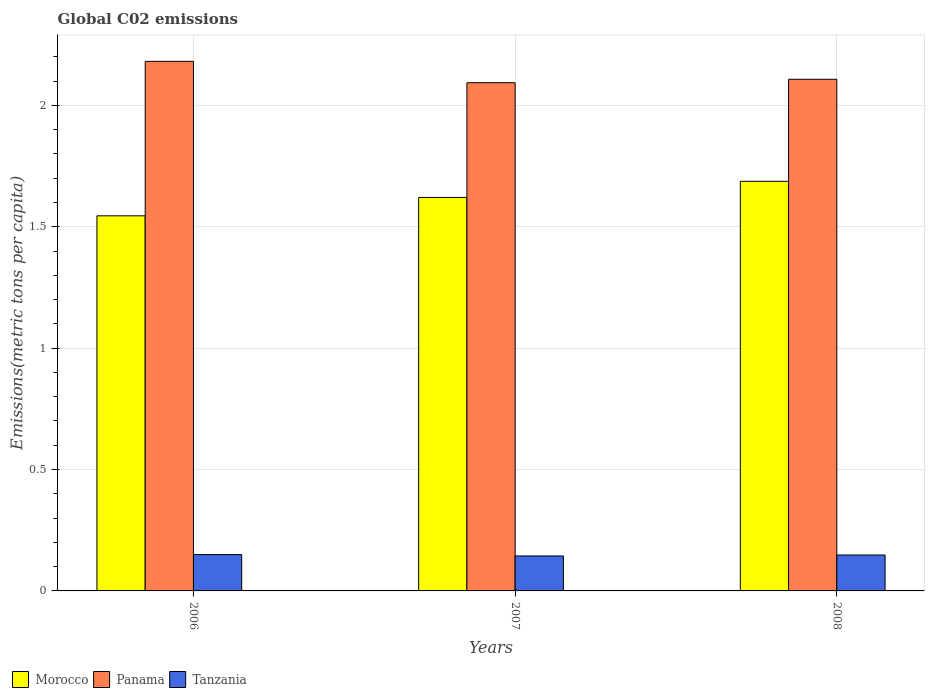How many different coloured bars are there?
Make the answer very short. 3. How many groups of bars are there?
Provide a succinct answer. 3. How many bars are there on the 3rd tick from the left?
Offer a very short reply. 3. What is the amount of CO2 emitted in in Tanzania in 2008?
Offer a very short reply. 0.15. Across all years, what is the maximum amount of CO2 emitted in in Tanzania?
Ensure brevity in your answer.  0.15. Across all years, what is the minimum amount of CO2 emitted in in Morocco?
Your answer should be very brief. 1.55. In which year was the amount of CO2 emitted in in Tanzania minimum?
Give a very brief answer. 2007. What is the total amount of CO2 emitted in in Panama in the graph?
Provide a succinct answer. 6.38. What is the difference between the amount of CO2 emitted in in Tanzania in 2007 and that in 2008?
Your answer should be compact. -0. What is the difference between the amount of CO2 emitted in in Morocco in 2008 and the amount of CO2 emitted in in Tanzania in 2006?
Your answer should be very brief. 1.54. What is the average amount of CO2 emitted in in Morocco per year?
Give a very brief answer. 1.62. In the year 2007, what is the difference between the amount of CO2 emitted in in Panama and amount of CO2 emitted in in Tanzania?
Your answer should be very brief. 1.95. What is the ratio of the amount of CO2 emitted in in Morocco in 2007 to that in 2008?
Keep it short and to the point. 0.96. Is the amount of CO2 emitted in in Morocco in 2007 less than that in 2008?
Ensure brevity in your answer.  Yes. What is the difference between the highest and the second highest amount of CO2 emitted in in Tanzania?
Make the answer very short. 0. What is the difference between the highest and the lowest amount of CO2 emitted in in Morocco?
Give a very brief answer. 0.14. What does the 1st bar from the left in 2006 represents?
Your answer should be compact. Morocco. What does the 3rd bar from the right in 2007 represents?
Keep it short and to the point. Morocco. Is it the case that in every year, the sum of the amount of CO2 emitted in in Tanzania and amount of CO2 emitted in in Panama is greater than the amount of CO2 emitted in in Morocco?
Your answer should be very brief. Yes. How many years are there in the graph?
Provide a short and direct response. 3. Where does the legend appear in the graph?
Offer a very short reply. Bottom left. How are the legend labels stacked?
Your answer should be compact. Horizontal. What is the title of the graph?
Provide a succinct answer. Global C02 emissions. What is the label or title of the Y-axis?
Your answer should be very brief. Emissions(metric tons per capita). What is the Emissions(metric tons per capita) in Morocco in 2006?
Offer a terse response. 1.55. What is the Emissions(metric tons per capita) in Panama in 2006?
Give a very brief answer. 2.18. What is the Emissions(metric tons per capita) in Tanzania in 2006?
Offer a terse response. 0.15. What is the Emissions(metric tons per capita) of Morocco in 2007?
Ensure brevity in your answer.  1.62. What is the Emissions(metric tons per capita) of Panama in 2007?
Offer a terse response. 2.09. What is the Emissions(metric tons per capita) of Tanzania in 2007?
Your response must be concise. 0.14. What is the Emissions(metric tons per capita) in Morocco in 2008?
Provide a short and direct response. 1.69. What is the Emissions(metric tons per capita) in Panama in 2008?
Give a very brief answer. 2.11. What is the Emissions(metric tons per capita) of Tanzania in 2008?
Provide a short and direct response. 0.15. Across all years, what is the maximum Emissions(metric tons per capita) of Morocco?
Give a very brief answer. 1.69. Across all years, what is the maximum Emissions(metric tons per capita) of Panama?
Your answer should be very brief. 2.18. Across all years, what is the maximum Emissions(metric tons per capita) in Tanzania?
Offer a very short reply. 0.15. Across all years, what is the minimum Emissions(metric tons per capita) of Morocco?
Make the answer very short. 1.55. Across all years, what is the minimum Emissions(metric tons per capita) of Panama?
Offer a very short reply. 2.09. Across all years, what is the minimum Emissions(metric tons per capita) of Tanzania?
Your answer should be very brief. 0.14. What is the total Emissions(metric tons per capita) of Morocco in the graph?
Your response must be concise. 4.85. What is the total Emissions(metric tons per capita) in Panama in the graph?
Your answer should be very brief. 6.38. What is the total Emissions(metric tons per capita) of Tanzania in the graph?
Your response must be concise. 0.44. What is the difference between the Emissions(metric tons per capita) in Morocco in 2006 and that in 2007?
Make the answer very short. -0.08. What is the difference between the Emissions(metric tons per capita) in Panama in 2006 and that in 2007?
Provide a succinct answer. 0.09. What is the difference between the Emissions(metric tons per capita) of Tanzania in 2006 and that in 2007?
Your response must be concise. 0.01. What is the difference between the Emissions(metric tons per capita) in Morocco in 2006 and that in 2008?
Offer a terse response. -0.14. What is the difference between the Emissions(metric tons per capita) of Panama in 2006 and that in 2008?
Make the answer very short. 0.07. What is the difference between the Emissions(metric tons per capita) of Tanzania in 2006 and that in 2008?
Offer a very short reply. 0. What is the difference between the Emissions(metric tons per capita) of Morocco in 2007 and that in 2008?
Keep it short and to the point. -0.07. What is the difference between the Emissions(metric tons per capita) of Panama in 2007 and that in 2008?
Your response must be concise. -0.01. What is the difference between the Emissions(metric tons per capita) in Tanzania in 2007 and that in 2008?
Your answer should be very brief. -0. What is the difference between the Emissions(metric tons per capita) in Morocco in 2006 and the Emissions(metric tons per capita) in Panama in 2007?
Keep it short and to the point. -0.55. What is the difference between the Emissions(metric tons per capita) of Morocco in 2006 and the Emissions(metric tons per capita) of Tanzania in 2007?
Offer a very short reply. 1.4. What is the difference between the Emissions(metric tons per capita) of Panama in 2006 and the Emissions(metric tons per capita) of Tanzania in 2007?
Give a very brief answer. 2.04. What is the difference between the Emissions(metric tons per capita) of Morocco in 2006 and the Emissions(metric tons per capita) of Panama in 2008?
Offer a terse response. -0.56. What is the difference between the Emissions(metric tons per capita) in Morocco in 2006 and the Emissions(metric tons per capita) in Tanzania in 2008?
Make the answer very short. 1.4. What is the difference between the Emissions(metric tons per capita) of Panama in 2006 and the Emissions(metric tons per capita) of Tanzania in 2008?
Keep it short and to the point. 2.03. What is the difference between the Emissions(metric tons per capita) of Morocco in 2007 and the Emissions(metric tons per capita) of Panama in 2008?
Keep it short and to the point. -0.49. What is the difference between the Emissions(metric tons per capita) of Morocco in 2007 and the Emissions(metric tons per capita) of Tanzania in 2008?
Ensure brevity in your answer.  1.47. What is the difference between the Emissions(metric tons per capita) of Panama in 2007 and the Emissions(metric tons per capita) of Tanzania in 2008?
Ensure brevity in your answer.  1.95. What is the average Emissions(metric tons per capita) of Morocco per year?
Your answer should be compact. 1.62. What is the average Emissions(metric tons per capita) of Panama per year?
Make the answer very short. 2.13. What is the average Emissions(metric tons per capita) of Tanzania per year?
Ensure brevity in your answer.  0.15. In the year 2006, what is the difference between the Emissions(metric tons per capita) in Morocco and Emissions(metric tons per capita) in Panama?
Ensure brevity in your answer.  -0.64. In the year 2006, what is the difference between the Emissions(metric tons per capita) in Morocco and Emissions(metric tons per capita) in Tanzania?
Your response must be concise. 1.4. In the year 2006, what is the difference between the Emissions(metric tons per capita) in Panama and Emissions(metric tons per capita) in Tanzania?
Your answer should be compact. 2.03. In the year 2007, what is the difference between the Emissions(metric tons per capita) of Morocco and Emissions(metric tons per capita) of Panama?
Keep it short and to the point. -0.47. In the year 2007, what is the difference between the Emissions(metric tons per capita) in Morocco and Emissions(metric tons per capita) in Tanzania?
Offer a very short reply. 1.48. In the year 2007, what is the difference between the Emissions(metric tons per capita) in Panama and Emissions(metric tons per capita) in Tanzania?
Your answer should be compact. 1.95. In the year 2008, what is the difference between the Emissions(metric tons per capita) in Morocco and Emissions(metric tons per capita) in Panama?
Your response must be concise. -0.42. In the year 2008, what is the difference between the Emissions(metric tons per capita) in Morocco and Emissions(metric tons per capita) in Tanzania?
Provide a short and direct response. 1.54. In the year 2008, what is the difference between the Emissions(metric tons per capita) of Panama and Emissions(metric tons per capita) of Tanzania?
Keep it short and to the point. 1.96. What is the ratio of the Emissions(metric tons per capita) in Morocco in 2006 to that in 2007?
Keep it short and to the point. 0.95. What is the ratio of the Emissions(metric tons per capita) of Panama in 2006 to that in 2007?
Provide a succinct answer. 1.04. What is the ratio of the Emissions(metric tons per capita) in Tanzania in 2006 to that in 2007?
Make the answer very short. 1.04. What is the ratio of the Emissions(metric tons per capita) in Morocco in 2006 to that in 2008?
Keep it short and to the point. 0.92. What is the ratio of the Emissions(metric tons per capita) of Panama in 2006 to that in 2008?
Offer a terse response. 1.03. What is the ratio of the Emissions(metric tons per capita) of Tanzania in 2006 to that in 2008?
Offer a terse response. 1.01. What is the ratio of the Emissions(metric tons per capita) of Morocco in 2007 to that in 2008?
Provide a short and direct response. 0.96. What is the ratio of the Emissions(metric tons per capita) in Tanzania in 2007 to that in 2008?
Make the answer very short. 0.97. What is the difference between the highest and the second highest Emissions(metric tons per capita) in Morocco?
Provide a succinct answer. 0.07. What is the difference between the highest and the second highest Emissions(metric tons per capita) in Panama?
Make the answer very short. 0.07. What is the difference between the highest and the second highest Emissions(metric tons per capita) of Tanzania?
Your answer should be very brief. 0. What is the difference between the highest and the lowest Emissions(metric tons per capita) of Morocco?
Offer a very short reply. 0.14. What is the difference between the highest and the lowest Emissions(metric tons per capita) of Panama?
Offer a very short reply. 0.09. What is the difference between the highest and the lowest Emissions(metric tons per capita) in Tanzania?
Your response must be concise. 0.01. 